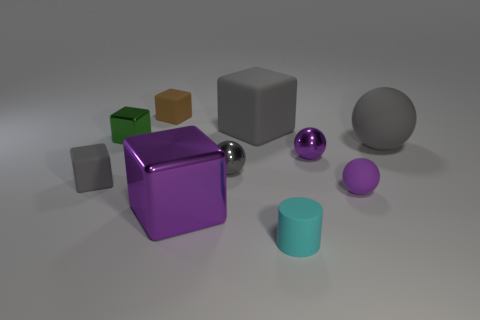There is a thing behind the gray cube behind the green metallic thing; how big is it?
Ensure brevity in your answer.  Small. The tiny rubber object that is the same color as the large metal thing is what shape?
Make the answer very short. Sphere. What number of cylinders are either big gray objects or gray objects?
Give a very brief answer. 0. Is the size of the green metallic block the same as the rubber block that is in front of the tiny green thing?
Keep it short and to the point. Yes. Are there more small brown matte objects to the left of the big gray ball than yellow metal cubes?
Make the answer very short. Yes. What is the size of the other block that is made of the same material as the green cube?
Offer a very short reply. Large. Is there a rubber ball that has the same color as the large metal cube?
Provide a succinct answer. Yes. What number of things are large things or purple balls on the left side of the small purple matte object?
Your answer should be very brief. 4. Is the number of small brown rubber cubes greater than the number of large matte things?
Keep it short and to the point. No. What is the size of the other rubber cube that is the same color as the big matte block?
Offer a very short reply. Small. 